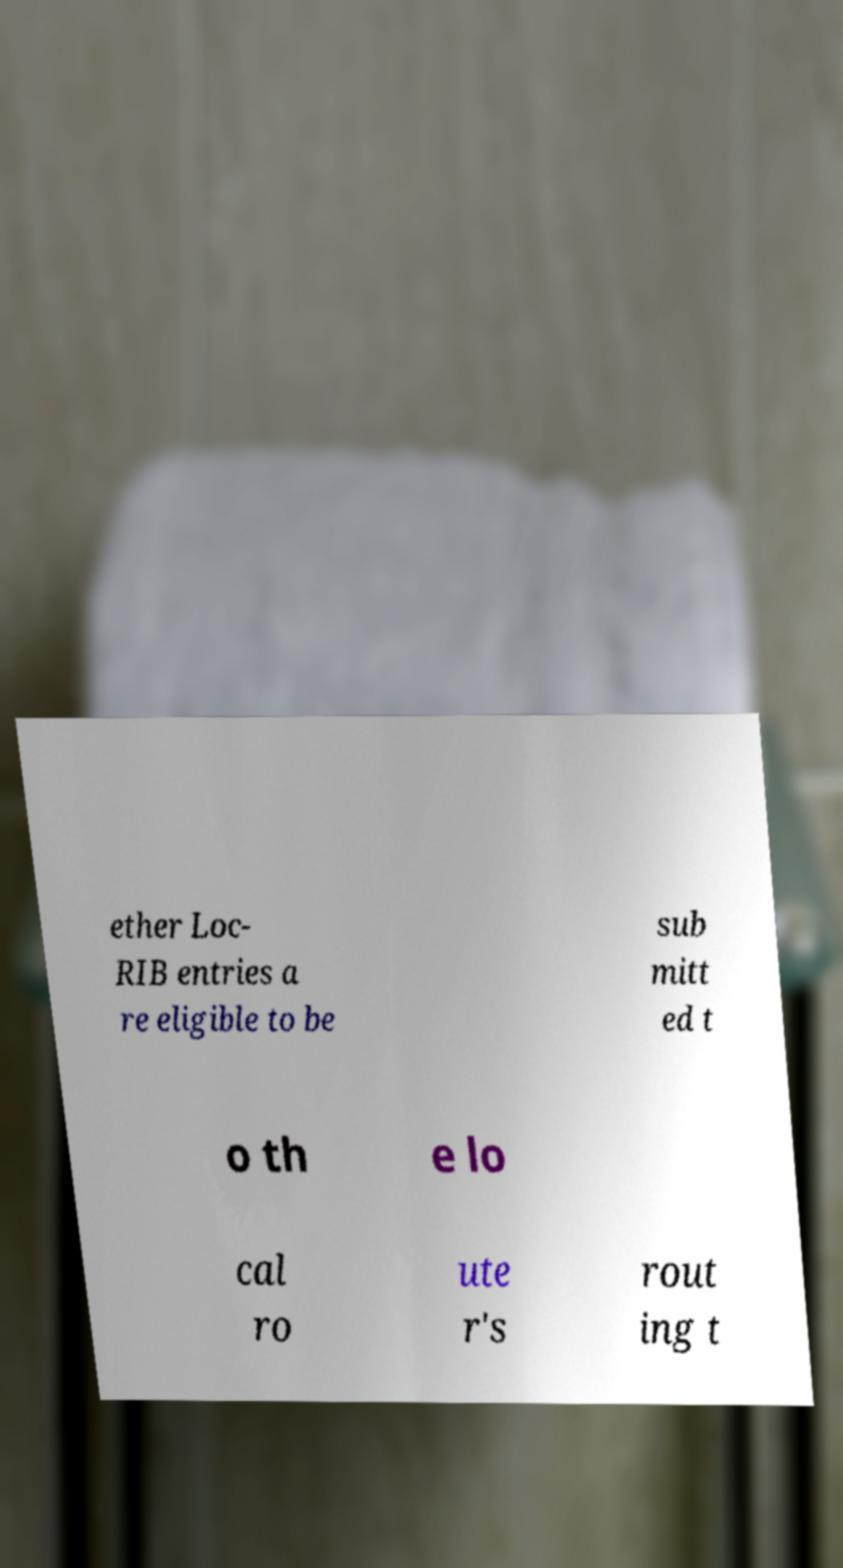Could you extract and type out the text from this image? ether Loc- RIB entries a re eligible to be sub mitt ed t o th e lo cal ro ute r's rout ing t 